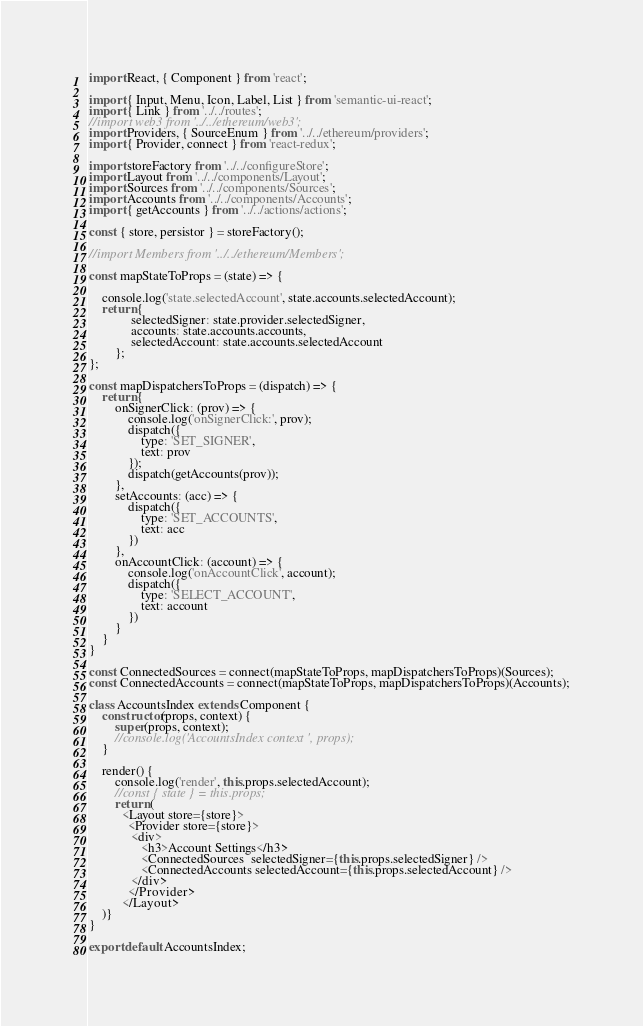Convert code to text. <code><loc_0><loc_0><loc_500><loc_500><_JavaScript_>import React, { Component } from 'react';

import { Input, Menu, Icon, Label, List } from 'semantic-ui-react';
import { Link } from '../../routes';
//import web3 from '../../ethereum/web3';
import Providers, { SourceEnum } from '../../ethereum/providers';
import { Provider, connect } from 'react-redux';

import storeFactory from '../../configureStore';
import Layout from '../../components/Layout';
import Sources from '../../components/Sources';
import Accounts from '../../components/Accounts';
import { getAccounts } from '../../actions/actions';

const { store, persistor } = storeFactory();

//import Members from '../../ethereum/Members';

const mapStateToProps = (state) => {

	console.log('state.selectedAccount', state.accounts.selectedAccount);
	return { 
			 selectedSigner: state.provider.selectedSigner,
			 accounts: state.accounts.accounts,
			 selectedAccount: state.accounts.selectedAccount
		};
};

const mapDispatchersToProps = (dispatch) => {
	return {
		onSignerClick: (prov) => {
			console.log('onSignerClick:', prov);
			dispatch({
				type: 'SET_SIGNER',
				text: prov
			});
			dispatch(getAccounts(prov));
		},
		setAccounts: (acc) => {
			dispatch({
				type: 'SET_ACCOUNTS',
				text: acc
			})
		},
		onAccountClick: (account) => {
			console.log('onAccountClick', account);
			dispatch({
				type: 'SELECT_ACCOUNT',
				text: account
			})
		}
	}
}

const ConnectedSources = connect(mapStateToProps, mapDispatchersToProps)(Sources);
const ConnectedAccounts = connect(mapStateToProps, mapDispatchersToProps)(Accounts);

class AccountsIndex extends Component {
	constructor(props, context) {
		super(props, context);
		//console.log('AccountsIndex context ', props);
	}
	
	render() {
		console.log('render', this.props.selectedAccount);
		//const { state } = this.props;
		return (
		  <Layout store={store}>
			<Provider store={store}>
		     <div>
			    <h3>Account Settings</h3>
				<ConnectedSources  selectedSigner={this.props.selectedSigner} />
				<ConnectedAccounts selectedAccount={this.props.selectedAccount} />
		     </div>
			</Provider>
		  </Layout>
	)}
}

export default AccountsIndex;</code> 